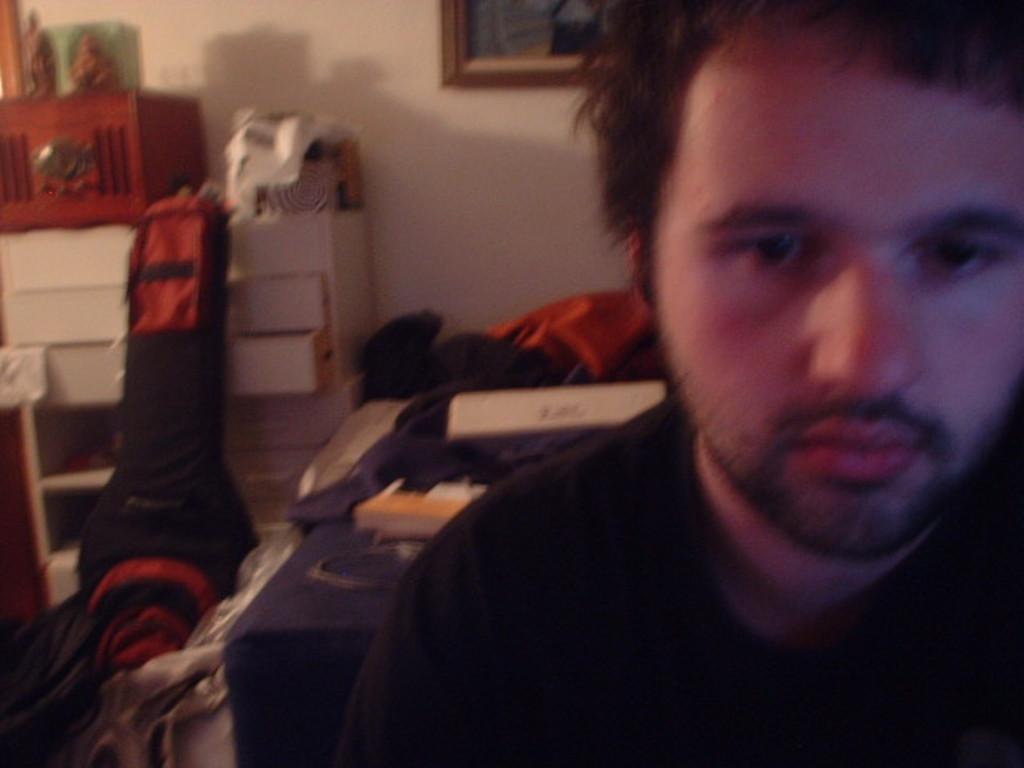Could you give a brief overview of what you see in this image? This picture shows a man and we see a guitar bag and few clothes and we see cupboard with drawers and couple of statues and we see a carry bag. 